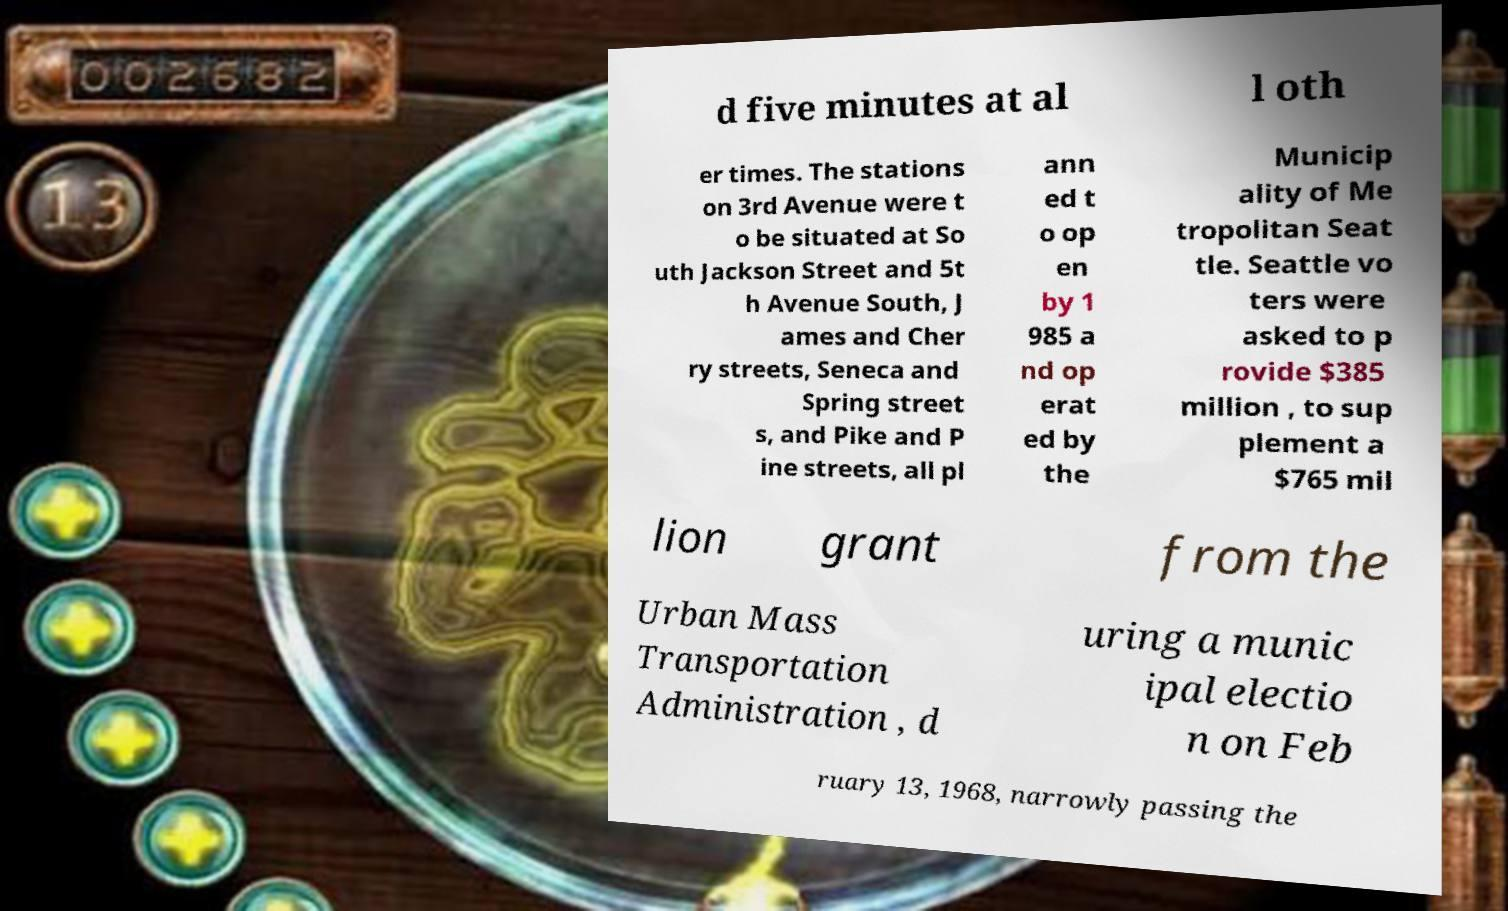Could you assist in decoding the text presented in this image and type it out clearly? d five minutes at al l oth er times. The stations on 3rd Avenue were t o be situated at So uth Jackson Street and 5t h Avenue South, J ames and Cher ry streets, Seneca and Spring street s, and Pike and P ine streets, all pl ann ed t o op en by 1 985 a nd op erat ed by the Municip ality of Me tropolitan Seat tle. Seattle vo ters were asked to p rovide $385 million , to sup plement a $765 mil lion grant from the Urban Mass Transportation Administration , d uring a munic ipal electio n on Feb ruary 13, 1968, narrowly passing the 